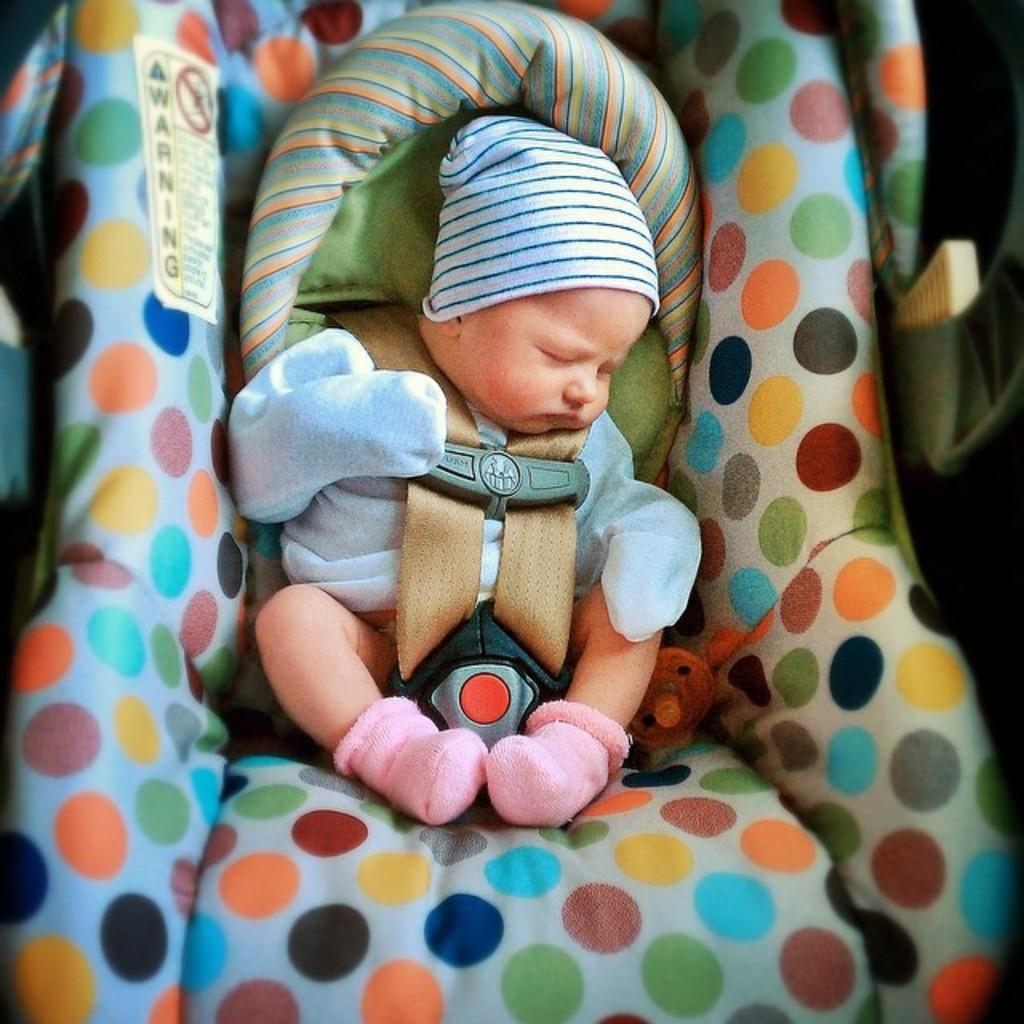Please provide a concise description of this image. A cute little baby is sleeping in the baby cloth, this baby wore cap,socks. 